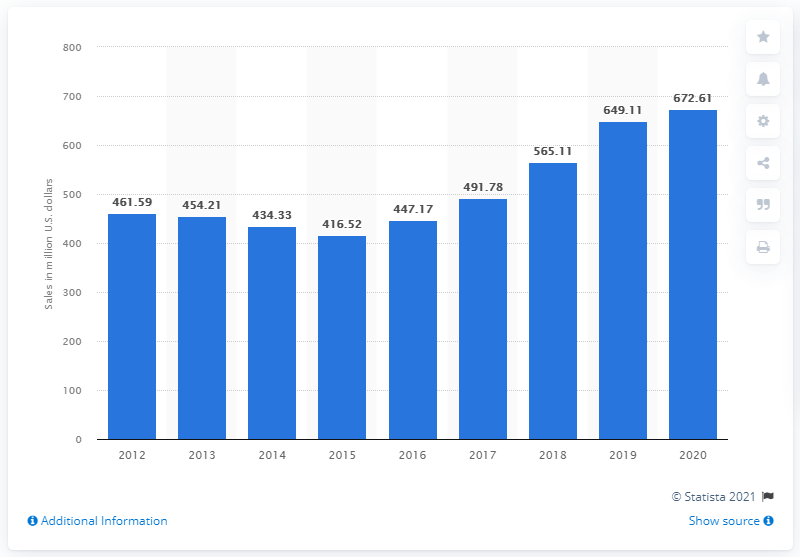Specify some key components in this picture. In 2021, the net revenue of lululemon athletica in Canada was CAD 672.61 million. In 2015, Lululemon athletica began to experience significant growth in its net sales. 